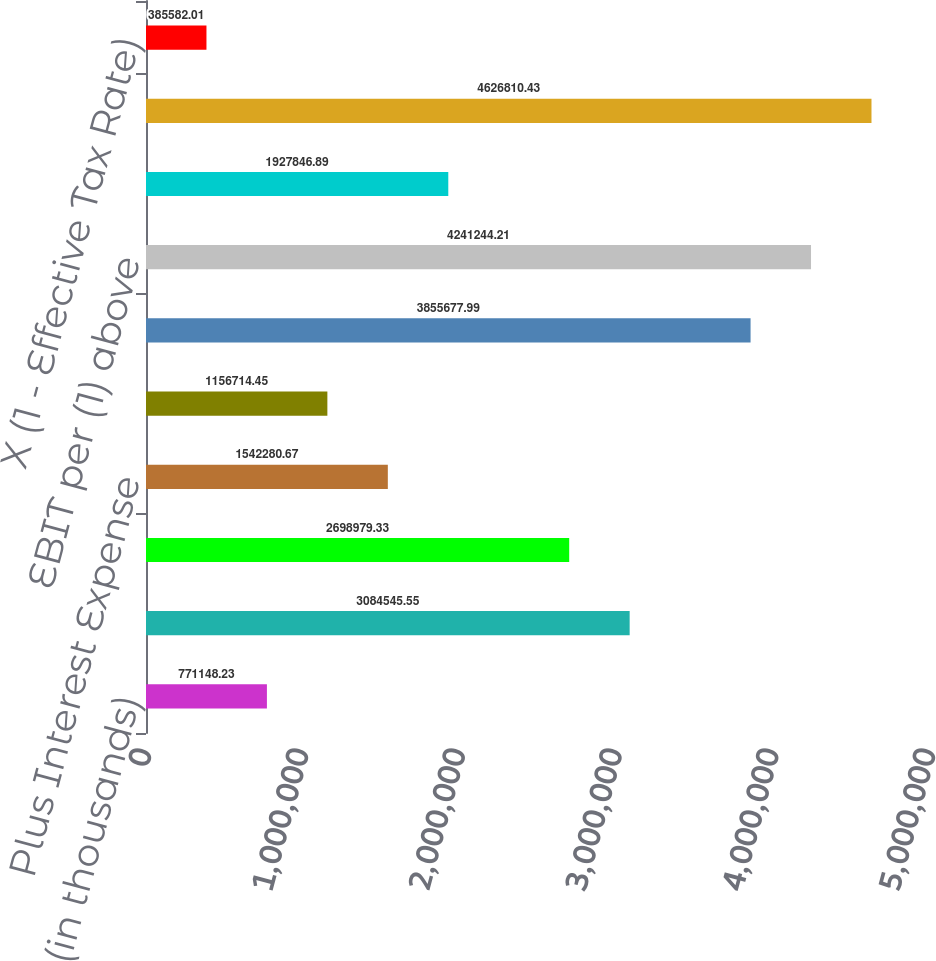Convert chart to OTSL. <chart><loc_0><loc_0><loc_500><loc_500><bar_chart><fcel>(in thousands)<fcel>Net Earnings Attributable to<fcel>Plus Income Tax Expense<fcel>Plus Interest Expense<fcel>Less Interest and Investment<fcel>EBIT<fcel>EBIT per (1) above<fcel>Plus Depreciation and<fcel>EBITDA<fcel>X (1 - Effective Tax Rate)<nl><fcel>771148<fcel>3.08455e+06<fcel>2.69898e+06<fcel>1.54228e+06<fcel>1.15671e+06<fcel>3.85568e+06<fcel>4.24124e+06<fcel>1.92785e+06<fcel>4.62681e+06<fcel>385582<nl></chart> 